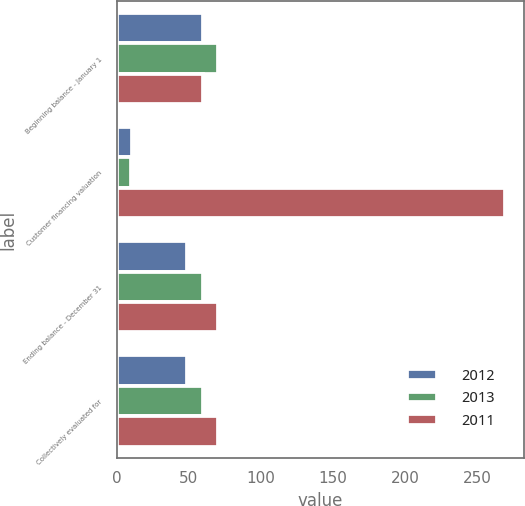Convert chart to OTSL. <chart><loc_0><loc_0><loc_500><loc_500><stacked_bar_chart><ecel><fcel>Beginning balance - January 1<fcel>Customer financing valuation<fcel>Ending balance - December 31<fcel>Collectively evaluated for<nl><fcel>2012<fcel>60<fcel>11<fcel>49<fcel>49<nl><fcel>2013<fcel>70<fcel>10<fcel>60<fcel>60<nl><fcel>2011<fcel>60<fcel>269<fcel>70<fcel>70<nl></chart> 